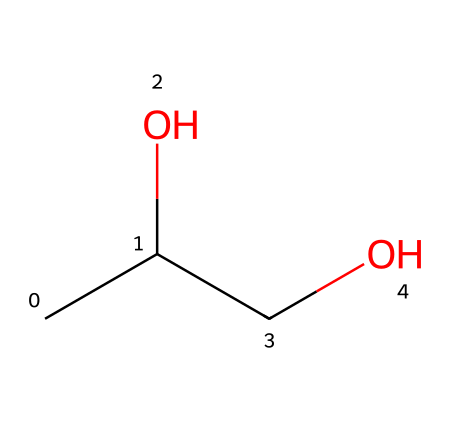What is the total number of carbon atoms in this molecule? By examining the SMILES structure, we can identify three carbon atoms (denoted by "C" in the molecular representation).
Answer: three How many hydroxyl (–OH) groups are present in this chemical? In the SMILES representation, the "O" showcases the presence of hydroxyl groups. There are two "O" atoms, indicating two hydroxyl groups.
Answer: two What type of chemical bonding is predominant in this structure? The structure contains single bonds between the carbon and oxygen atoms, and within the carbon atoms themselves, indicating that the predominant bonding type in this structure is sigma bonding.
Answer: sigma Is this chemical likely to be polar or non-polar? The presence of hydroxyl groups in the molecule indicates that it can form hydrogen bonds, resulting in a polar nature.
Answer: polar What functional groups are present in this compound? The SMILES notation includes the hydroxyl (-OH) groups, which are characteristic of alcohols, identifying the functional group as alcohols.
Answer: alcohol What is the main use of this chemical in young artist paints? Due to its water-soluble properties and safety profile, this alcohol is often used as a solvent or binder in washable paints for children.
Answer: solvent 